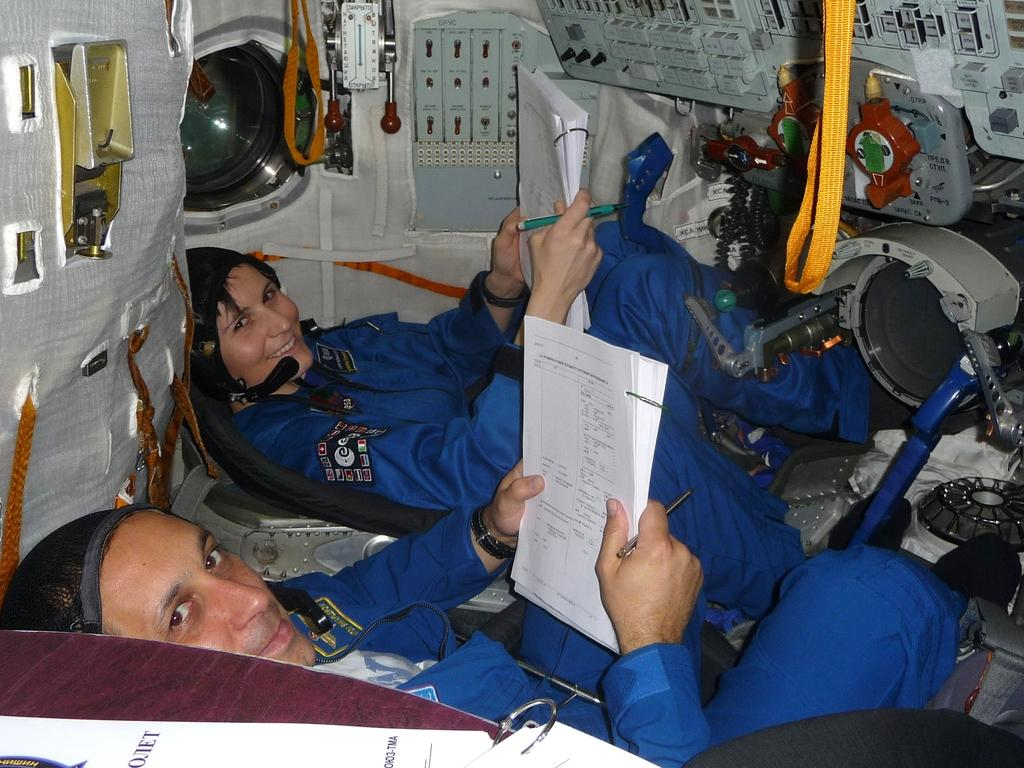How many people are in the image? There are two persons in the image. What are the persons doing in the image? The persons are sitting in the image. What are the persons holding in their hands? The persons are holding something in their hands in the image. What type of location is depicted in the image? The image appears to be an inner view of a spacecraft. What else can be seen in the image besides the persons? There are machines and other objects visible in the image. What is the profit margin of the bit in the image? There is no bit present in the image, so it is not possible to determine the profit margin. 